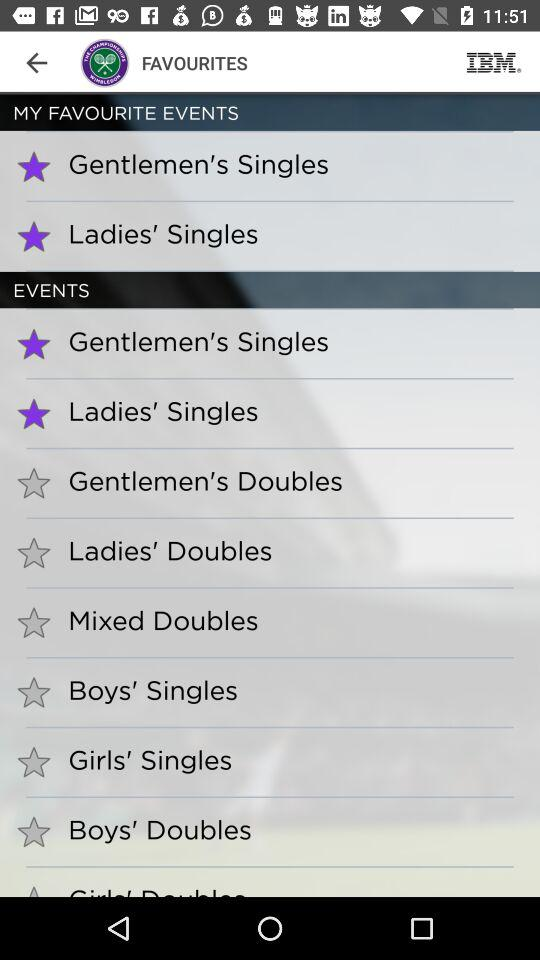Which are my favourite events? The favourite events are "Gentlemen's Singles" and "Ladies' Singles". 